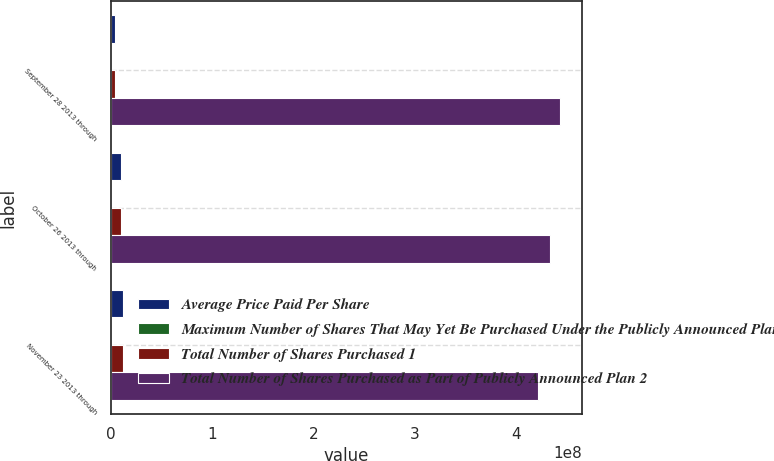Convert chart to OTSL. <chart><loc_0><loc_0><loc_500><loc_500><stacked_bar_chart><ecel><fcel>September 28 2013 through<fcel>October 26 2013 through<fcel>November 23 2013 through<nl><fcel>Average Price Paid Per Share<fcel>3.88179e+06<fcel>9.83799e+06<fcel>1.16288e+07<nl><fcel>Maximum Number of Shares That May Yet Be Purchased Under the Publicly Announced Plan<fcel>38.54<fcel>39.93<fcel>40.14<nl><fcel>Total Number of Shares Purchased 1<fcel>3.88e+06<fcel>9.7955e+06<fcel>1.16093e+07<nl><fcel>Total Number of Shares Purchased as Part of Publicly Announced Plan 2<fcel>4.43184e+08<fcel>4.33388e+08<fcel>4.21779e+08<nl></chart> 